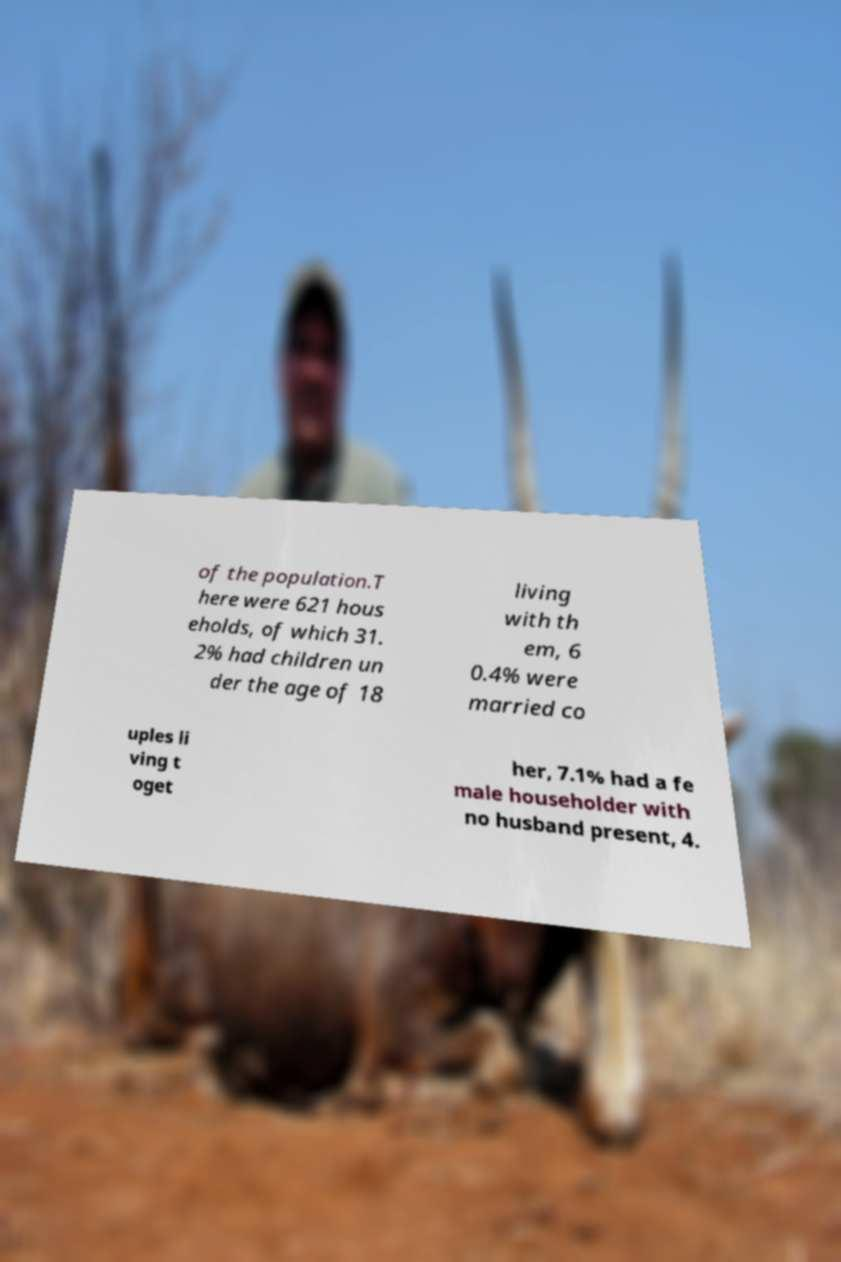Could you assist in decoding the text presented in this image and type it out clearly? of the population.T here were 621 hous eholds, of which 31. 2% had children un der the age of 18 living with th em, 6 0.4% were married co uples li ving t oget her, 7.1% had a fe male householder with no husband present, 4. 